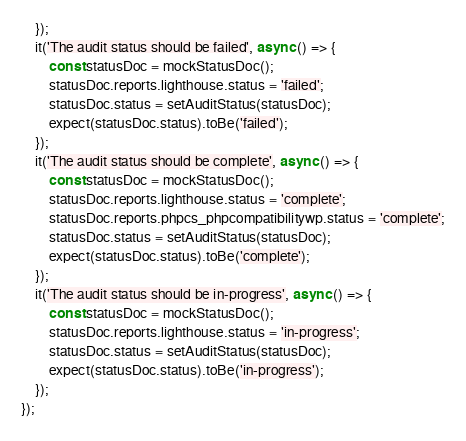Convert code to text. <code><loc_0><loc_0><loc_500><loc_500><_JavaScript_>    });
    it('The audit status should be failed', async () => {
        const statusDoc = mockStatusDoc();
        statusDoc.reports.lighthouse.status = 'failed';
        statusDoc.status = setAuditStatus(statusDoc);
        expect(statusDoc.status).toBe('failed');
    });
    it('The audit status should be complete', async () => {
        const statusDoc = mockStatusDoc();
        statusDoc.reports.lighthouse.status = 'complete';
        statusDoc.reports.phpcs_phpcompatibilitywp.status = 'complete';
        statusDoc.status = setAuditStatus(statusDoc);
        expect(statusDoc.status).toBe('complete');
    });
    it('The audit status should be in-progress', async () => {
        const statusDoc = mockStatusDoc();
        statusDoc.reports.lighthouse.status = 'in-progress';
        statusDoc.status = setAuditStatus(statusDoc);
        expect(statusDoc.status).toBe('in-progress');
    });
});
</code> 